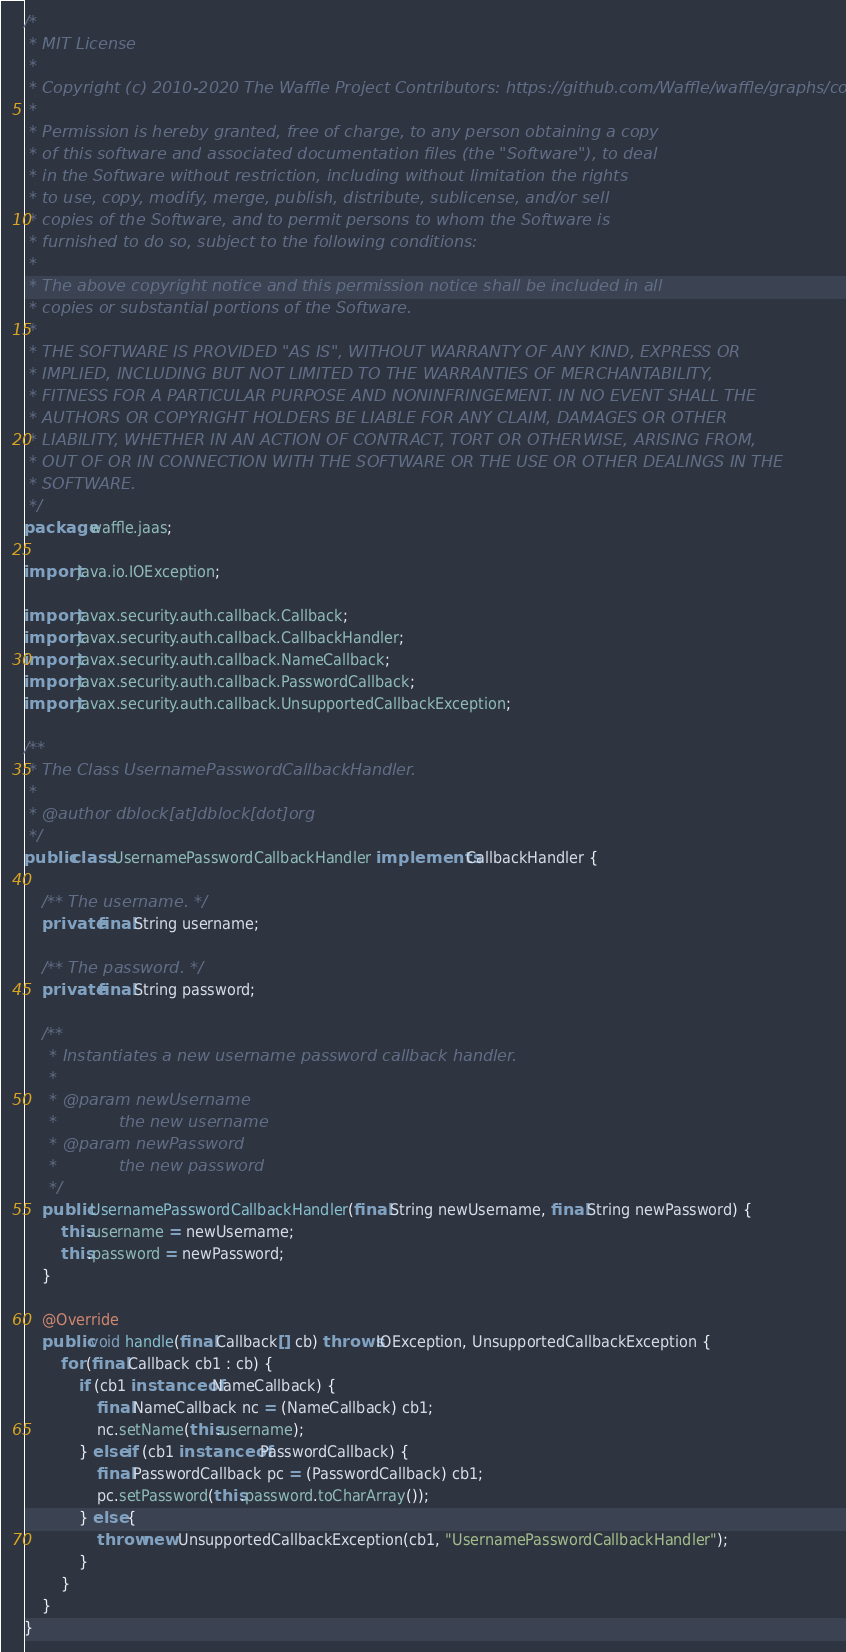Convert code to text. <code><loc_0><loc_0><loc_500><loc_500><_Java_>/*
 * MIT License
 *
 * Copyright (c) 2010-2020 The Waffle Project Contributors: https://github.com/Waffle/waffle/graphs/contributors
 *
 * Permission is hereby granted, free of charge, to any person obtaining a copy
 * of this software and associated documentation files (the "Software"), to deal
 * in the Software without restriction, including without limitation the rights
 * to use, copy, modify, merge, publish, distribute, sublicense, and/or sell
 * copies of the Software, and to permit persons to whom the Software is
 * furnished to do so, subject to the following conditions:
 *
 * The above copyright notice and this permission notice shall be included in all
 * copies or substantial portions of the Software.
 *
 * THE SOFTWARE IS PROVIDED "AS IS", WITHOUT WARRANTY OF ANY KIND, EXPRESS OR
 * IMPLIED, INCLUDING BUT NOT LIMITED TO THE WARRANTIES OF MERCHANTABILITY,
 * FITNESS FOR A PARTICULAR PURPOSE AND NONINFRINGEMENT. IN NO EVENT SHALL THE
 * AUTHORS OR COPYRIGHT HOLDERS BE LIABLE FOR ANY CLAIM, DAMAGES OR OTHER
 * LIABILITY, WHETHER IN AN ACTION OF CONTRACT, TORT OR OTHERWISE, ARISING FROM,
 * OUT OF OR IN CONNECTION WITH THE SOFTWARE OR THE USE OR OTHER DEALINGS IN THE
 * SOFTWARE.
 */
package waffle.jaas;

import java.io.IOException;

import javax.security.auth.callback.Callback;
import javax.security.auth.callback.CallbackHandler;
import javax.security.auth.callback.NameCallback;
import javax.security.auth.callback.PasswordCallback;
import javax.security.auth.callback.UnsupportedCallbackException;

/**
 * The Class UsernamePasswordCallbackHandler.
 *
 * @author dblock[at]dblock[dot]org
 */
public class UsernamePasswordCallbackHandler implements CallbackHandler {

    /** The username. */
    private final String username;

    /** The password. */
    private final String password;

    /**
     * Instantiates a new username password callback handler.
     *
     * @param newUsername
     *            the new username
     * @param newPassword
     *            the new password
     */
    public UsernamePasswordCallbackHandler(final String newUsername, final String newPassword) {
        this.username = newUsername;
        this.password = newPassword;
    }

    @Override
    public void handle(final Callback[] cb) throws IOException, UnsupportedCallbackException {
        for (final Callback cb1 : cb) {
            if (cb1 instanceof NameCallback) {
                final NameCallback nc = (NameCallback) cb1;
                nc.setName(this.username);
            } else if (cb1 instanceof PasswordCallback) {
                final PasswordCallback pc = (PasswordCallback) cb1;
                pc.setPassword(this.password.toCharArray());
            } else {
                throw new UnsupportedCallbackException(cb1, "UsernamePasswordCallbackHandler");
            }
        }
    }
}
</code> 